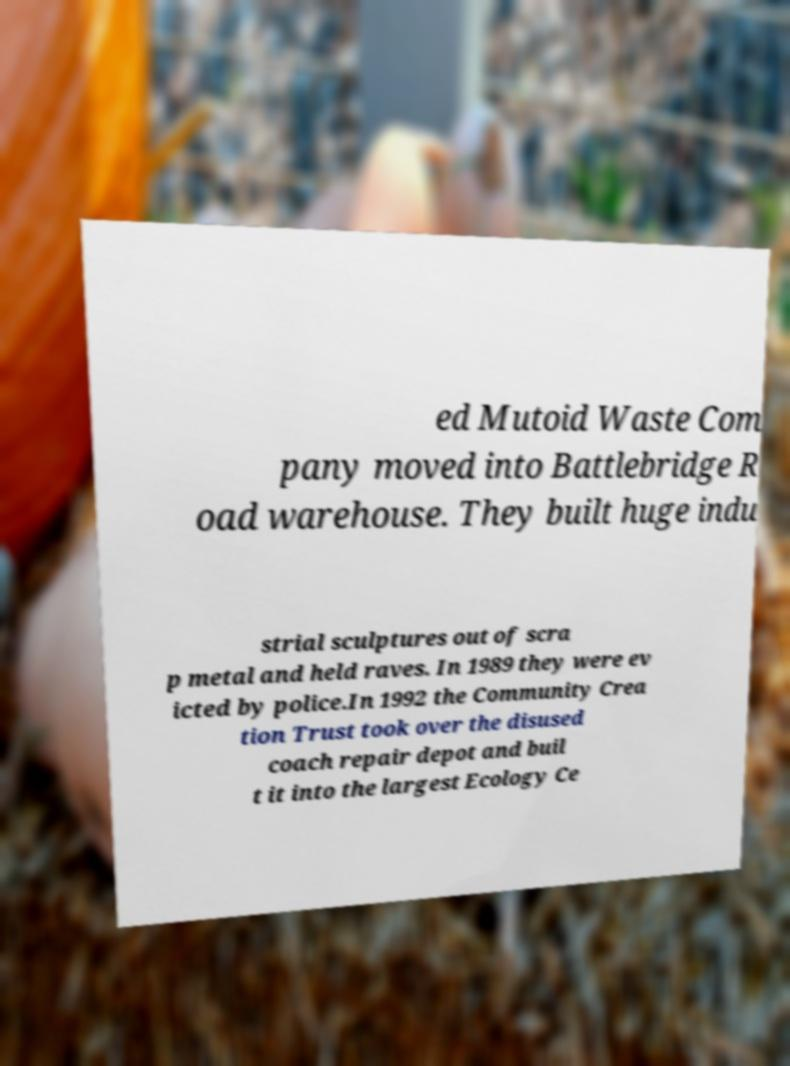What messages or text are displayed in this image? I need them in a readable, typed format. ed Mutoid Waste Com pany moved into Battlebridge R oad warehouse. They built huge indu strial sculptures out of scra p metal and held raves. In 1989 they were ev icted by police.In 1992 the Community Crea tion Trust took over the disused coach repair depot and buil t it into the largest Ecology Ce 